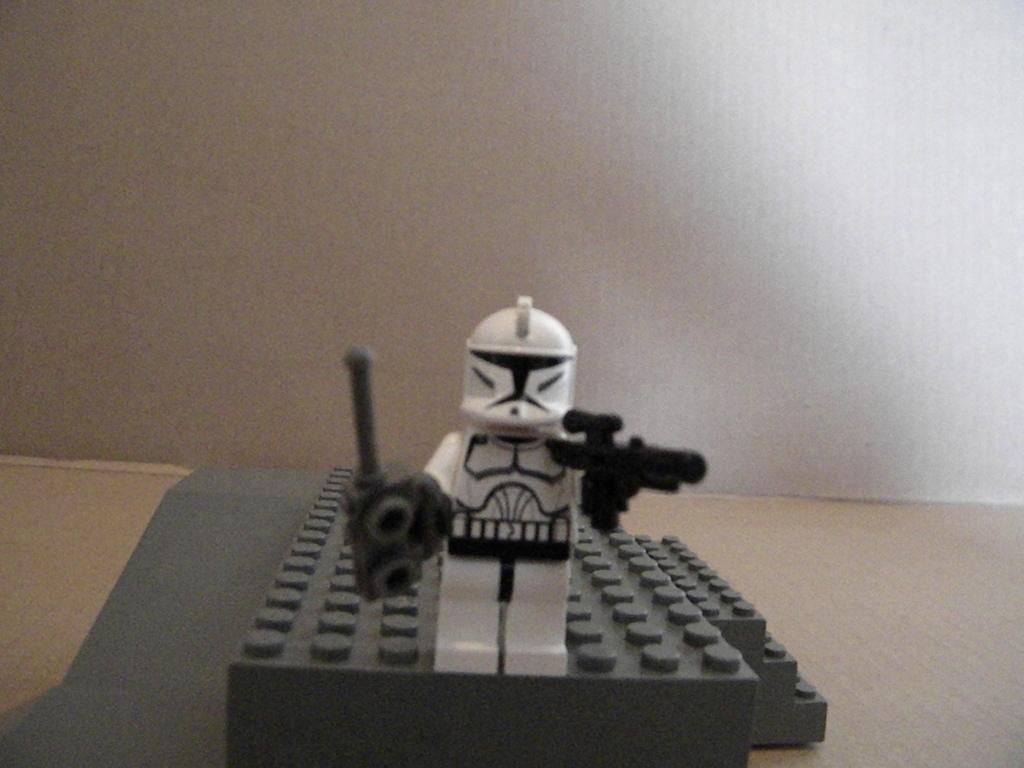What is the main object in the image? There is a toy in the image. What color is the toy? The toy is in black and white color. What is the toy standing on? The toy is standing on a board. What color is the board? The board is in gray color. What color is the background of the image? The background of the image is in white color. Can you hear the toy whistling in the image? There is no indication of sound or a whistle in the image. 